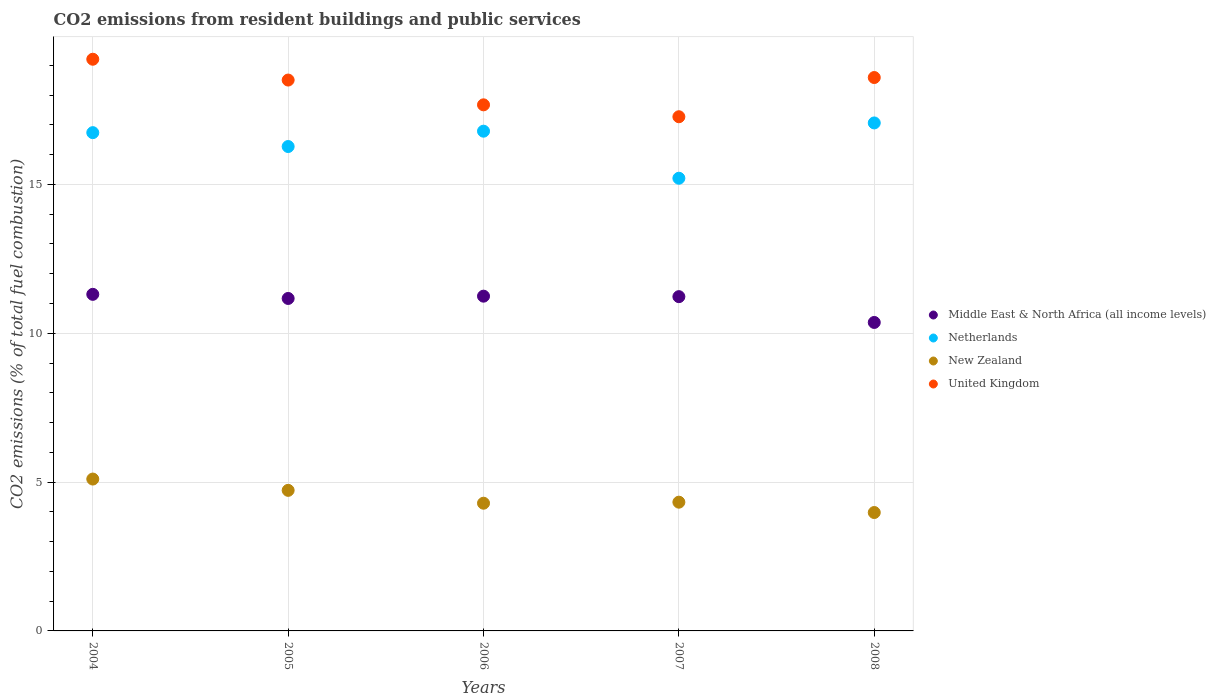What is the total CO2 emitted in Netherlands in 2006?
Your answer should be compact. 16.79. Across all years, what is the maximum total CO2 emitted in Netherlands?
Ensure brevity in your answer.  17.07. Across all years, what is the minimum total CO2 emitted in Middle East & North Africa (all income levels)?
Offer a very short reply. 10.36. What is the total total CO2 emitted in Netherlands in the graph?
Make the answer very short. 82.08. What is the difference between the total CO2 emitted in United Kingdom in 2004 and that in 2005?
Ensure brevity in your answer.  0.7. What is the difference between the total CO2 emitted in Middle East & North Africa (all income levels) in 2006 and the total CO2 emitted in New Zealand in 2005?
Your answer should be compact. 6.52. What is the average total CO2 emitted in Middle East & North Africa (all income levels) per year?
Your answer should be very brief. 11.06. In the year 2006, what is the difference between the total CO2 emitted in New Zealand and total CO2 emitted in Netherlands?
Your answer should be compact. -12.5. What is the ratio of the total CO2 emitted in Middle East & North Africa (all income levels) in 2005 to that in 2006?
Your answer should be compact. 0.99. Is the difference between the total CO2 emitted in New Zealand in 2004 and 2008 greater than the difference between the total CO2 emitted in Netherlands in 2004 and 2008?
Give a very brief answer. Yes. What is the difference between the highest and the second highest total CO2 emitted in Netherlands?
Provide a succinct answer. 0.28. What is the difference between the highest and the lowest total CO2 emitted in New Zealand?
Offer a terse response. 1.12. Is it the case that in every year, the sum of the total CO2 emitted in Netherlands and total CO2 emitted in New Zealand  is greater than the sum of total CO2 emitted in Middle East & North Africa (all income levels) and total CO2 emitted in United Kingdom?
Your response must be concise. No. Is it the case that in every year, the sum of the total CO2 emitted in Netherlands and total CO2 emitted in United Kingdom  is greater than the total CO2 emitted in New Zealand?
Your response must be concise. Yes. Is the total CO2 emitted in New Zealand strictly greater than the total CO2 emitted in United Kingdom over the years?
Give a very brief answer. No. How many years are there in the graph?
Keep it short and to the point. 5. Does the graph contain grids?
Your answer should be compact. Yes. Where does the legend appear in the graph?
Your answer should be compact. Center right. How many legend labels are there?
Keep it short and to the point. 4. How are the legend labels stacked?
Offer a very short reply. Vertical. What is the title of the graph?
Your answer should be compact. CO2 emissions from resident buildings and public services. Does "Europe(developing only)" appear as one of the legend labels in the graph?
Keep it short and to the point. No. What is the label or title of the Y-axis?
Your answer should be compact. CO2 emissions (% of total fuel combustion). What is the CO2 emissions (% of total fuel combustion) of Middle East & North Africa (all income levels) in 2004?
Keep it short and to the point. 11.31. What is the CO2 emissions (% of total fuel combustion) in Netherlands in 2004?
Your answer should be very brief. 16.74. What is the CO2 emissions (% of total fuel combustion) in New Zealand in 2004?
Make the answer very short. 5.1. What is the CO2 emissions (% of total fuel combustion) in United Kingdom in 2004?
Make the answer very short. 19.21. What is the CO2 emissions (% of total fuel combustion) in Middle East & North Africa (all income levels) in 2005?
Your answer should be compact. 11.17. What is the CO2 emissions (% of total fuel combustion) of Netherlands in 2005?
Your answer should be compact. 16.27. What is the CO2 emissions (% of total fuel combustion) in New Zealand in 2005?
Offer a terse response. 4.72. What is the CO2 emissions (% of total fuel combustion) of United Kingdom in 2005?
Provide a short and direct response. 18.51. What is the CO2 emissions (% of total fuel combustion) in Middle East & North Africa (all income levels) in 2006?
Your response must be concise. 11.25. What is the CO2 emissions (% of total fuel combustion) of Netherlands in 2006?
Your answer should be compact. 16.79. What is the CO2 emissions (% of total fuel combustion) in New Zealand in 2006?
Your response must be concise. 4.29. What is the CO2 emissions (% of total fuel combustion) of United Kingdom in 2006?
Provide a short and direct response. 17.67. What is the CO2 emissions (% of total fuel combustion) of Middle East & North Africa (all income levels) in 2007?
Your answer should be compact. 11.23. What is the CO2 emissions (% of total fuel combustion) in Netherlands in 2007?
Give a very brief answer. 15.21. What is the CO2 emissions (% of total fuel combustion) of New Zealand in 2007?
Make the answer very short. 4.33. What is the CO2 emissions (% of total fuel combustion) of United Kingdom in 2007?
Your answer should be very brief. 17.27. What is the CO2 emissions (% of total fuel combustion) of Middle East & North Africa (all income levels) in 2008?
Your response must be concise. 10.36. What is the CO2 emissions (% of total fuel combustion) in Netherlands in 2008?
Make the answer very short. 17.07. What is the CO2 emissions (% of total fuel combustion) in New Zealand in 2008?
Give a very brief answer. 3.98. What is the CO2 emissions (% of total fuel combustion) of United Kingdom in 2008?
Your response must be concise. 18.59. Across all years, what is the maximum CO2 emissions (% of total fuel combustion) of Middle East & North Africa (all income levels)?
Make the answer very short. 11.31. Across all years, what is the maximum CO2 emissions (% of total fuel combustion) in Netherlands?
Ensure brevity in your answer.  17.07. Across all years, what is the maximum CO2 emissions (% of total fuel combustion) of New Zealand?
Keep it short and to the point. 5.1. Across all years, what is the maximum CO2 emissions (% of total fuel combustion) of United Kingdom?
Give a very brief answer. 19.21. Across all years, what is the minimum CO2 emissions (% of total fuel combustion) in Middle East & North Africa (all income levels)?
Give a very brief answer. 10.36. Across all years, what is the minimum CO2 emissions (% of total fuel combustion) of Netherlands?
Offer a terse response. 15.21. Across all years, what is the minimum CO2 emissions (% of total fuel combustion) in New Zealand?
Provide a short and direct response. 3.98. Across all years, what is the minimum CO2 emissions (% of total fuel combustion) in United Kingdom?
Your answer should be very brief. 17.27. What is the total CO2 emissions (% of total fuel combustion) in Middle East & North Africa (all income levels) in the graph?
Offer a very short reply. 55.32. What is the total CO2 emissions (% of total fuel combustion) of Netherlands in the graph?
Make the answer very short. 82.08. What is the total CO2 emissions (% of total fuel combustion) in New Zealand in the graph?
Make the answer very short. 22.42. What is the total CO2 emissions (% of total fuel combustion) of United Kingdom in the graph?
Offer a very short reply. 91.25. What is the difference between the CO2 emissions (% of total fuel combustion) in Middle East & North Africa (all income levels) in 2004 and that in 2005?
Keep it short and to the point. 0.14. What is the difference between the CO2 emissions (% of total fuel combustion) of Netherlands in 2004 and that in 2005?
Your response must be concise. 0.47. What is the difference between the CO2 emissions (% of total fuel combustion) of New Zealand in 2004 and that in 2005?
Offer a very short reply. 0.38. What is the difference between the CO2 emissions (% of total fuel combustion) in United Kingdom in 2004 and that in 2005?
Your answer should be very brief. 0.7. What is the difference between the CO2 emissions (% of total fuel combustion) in Middle East & North Africa (all income levels) in 2004 and that in 2006?
Give a very brief answer. 0.06. What is the difference between the CO2 emissions (% of total fuel combustion) in Netherlands in 2004 and that in 2006?
Make the answer very short. -0.05. What is the difference between the CO2 emissions (% of total fuel combustion) of New Zealand in 2004 and that in 2006?
Provide a short and direct response. 0.81. What is the difference between the CO2 emissions (% of total fuel combustion) in United Kingdom in 2004 and that in 2006?
Your response must be concise. 1.53. What is the difference between the CO2 emissions (% of total fuel combustion) of Middle East & North Africa (all income levels) in 2004 and that in 2007?
Your response must be concise. 0.08. What is the difference between the CO2 emissions (% of total fuel combustion) in Netherlands in 2004 and that in 2007?
Offer a terse response. 1.53. What is the difference between the CO2 emissions (% of total fuel combustion) in New Zealand in 2004 and that in 2007?
Make the answer very short. 0.78. What is the difference between the CO2 emissions (% of total fuel combustion) of United Kingdom in 2004 and that in 2007?
Provide a succinct answer. 1.93. What is the difference between the CO2 emissions (% of total fuel combustion) of Netherlands in 2004 and that in 2008?
Ensure brevity in your answer.  -0.33. What is the difference between the CO2 emissions (% of total fuel combustion) in New Zealand in 2004 and that in 2008?
Offer a terse response. 1.12. What is the difference between the CO2 emissions (% of total fuel combustion) of United Kingdom in 2004 and that in 2008?
Provide a succinct answer. 0.61. What is the difference between the CO2 emissions (% of total fuel combustion) of Middle East & North Africa (all income levels) in 2005 and that in 2006?
Offer a terse response. -0.08. What is the difference between the CO2 emissions (% of total fuel combustion) of Netherlands in 2005 and that in 2006?
Keep it short and to the point. -0.52. What is the difference between the CO2 emissions (% of total fuel combustion) of New Zealand in 2005 and that in 2006?
Offer a terse response. 0.43. What is the difference between the CO2 emissions (% of total fuel combustion) in United Kingdom in 2005 and that in 2006?
Offer a terse response. 0.83. What is the difference between the CO2 emissions (% of total fuel combustion) of Middle East & North Africa (all income levels) in 2005 and that in 2007?
Your answer should be very brief. -0.06. What is the difference between the CO2 emissions (% of total fuel combustion) in Netherlands in 2005 and that in 2007?
Ensure brevity in your answer.  1.07. What is the difference between the CO2 emissions (% of total fuel combustion) of New Zealand in 2005 and that in 2007?
Make the answer very short. 0.4. What is the difference between the CO2 emissions (% of total fuel combustion) of United Kingdom in 2005 and that in 2007?
Offer a terse response. 1.23. What is the difference between the CO2 emissions (% of total fuel combustion) in Middle East & North Africa (all income levels) in 2005 and that in 2008?
Ensure brevity in your answer.  0.81. What is the difference between the CO2 emissions (% of total fuel combustion) in Netherlands in 2005 and that in 2008?
Provide a short and direct response. -0.79. What is the difference between the CO2 emissions (% of total fuel combustion) in New Zealand in 2005 and that in 2008?
Make the answer very short. 0.74. What is the difference between the CO2 emissions (% of total fuel combustion) of United Kingdom in 2005 and that in 2008?
Ensure brevity in your answer.  -0.08. What is the difference between the CO2 emissions (% of total fuel combustion) of Middle East & North Africa (all income levels) in 2006 and that in 2007?
Offer a very short reply. 0.02. What is the difference between the CO2 emissions (% of total fuel combustion) in Netherlands in 2006 and that in 2007?
Give a very brief answer. 1.58. What is the difference between the CO2 emissions (% of total fuel combustion) in New Zealand in 2006 and that in 2007?
Ensure brevity in your answer.  -0.04. What is the difference between the CO2 emissions (% of total fuel combustion) of United Kingdom in 2006 and that in 2007?
Offer a terse response. 0.4. What is the difference between the CO2 emissions (% of total fuel combustion) of Middle East & North Africa (all income levels) in 2006 and that in 2008?
Offer a very short reply. 0.88. What is the difference between the CO2 emissions (% of total fuel combustion) of Netherlands in 2006 and that in 2008?
Provide a short and direct response. -0.28. What is the difference between the CO2 emissions (% of total fuel combustion) in New Zealand in 2006 and that in 2008?
Make the answer very short. 0.31. What is the difference between the CO2 emissions (% of total fuel combustion) in United Kingdom in 2006 and that in 2008?
Provide a succinct answer. -0.92. What is the difference between the CO2 emissions (% of total fuel combustion) of Middle East & North Africa (all income levels) in 2007 and that in 2008?
Offer a terse response. 0.87. What is the difference between the CO2 emissions (% of total fuel combustion) in Netherlands in 2007 and that in 2008?
Your answer should be compact. -1.86. What is the difference between the CO2 emissions (% of total fuel combustion) of New Zealand in 2007 and that in 2008?
Your response must be concise. 0.35. What is the difference between the CO2 emissions (% of total fuel combustion) in United Kingdom in 2007 and that in 2008?
Make the answer very short. -1.32. What is the difference between the CO2 emissions (% of total fuel combustion) in Middle East & North Africa (all income levels) in 2004 and the CO2 emissions (% of total fuel combustion) in Netherlands in 2005?
Give a very brief answer. -4.97. What is the difference between the CO2 emissions (% of total fuel combustion) of Middle East & North Africa (all income levels) in 2004 and the CO2 emissions (% of total fuel combustion) of New Zealand in 2005?
Offer a very short reply. 6.59. What is the difference between the CO2 emissions (% of total fuel combustion) of Middle East & North Africa (all income levels) in 2004 and the CO2 emissions (% of total fuel combustion) of United Kingdom in 2005?
Offer a terse response. -7.2. What is the difference between the CO2 emissions (% of total fuel combustion) of Netherlands in 2004 and the CO2 emissions (% of total fuel combustion) of New Zealand in 2005?
Offer a terse response. 12.02. What is the difference between the CO2 emissions (% of total fuel combustion) of Netherlands in 2004 and the CO2 emissions (% of total fuel combustion) of United Kingdom in 2005?
Keep it short and to the point. -1.77. What is the difference between the CO2 emissions (% of total fuel combustion) in New Zealand in 2004 and the CO2 emissions (% of total fuel combustion) in United Kingdom in 2005?
Offer a terse response. -13.4. What is the difference between the CO2 emissions (% of total fuel combustion) of Middle East & North Africa (all income levels) in 2004 and the CO2 emissions (% of total fuel combustion) of Netherlands in 2006?
Your answer should be very brief. -5.48. What is the difference between the CO2 emissions (% of total fuel combustion) in Middle East & North Africa (all income levels) in 2004 and the CO2 emissions (% of total fuel combustion) in New Zealand in 2006?
Offer a very short reply. 7.02. What is the difference between the CO2 emissions (% of total fuel combustion) in Middle East & North Africa (all income levels) in 2004 and the CO2 emissions (% of total fuel combustion) in United Kingdom in 2006?
Your answer should be compact. -6.37. What is the difference between the CO2 emissions (% of total fuel combustion) of Netherlands in 2004 and the CO2 emissions (% of total fuel combustion) of New Zealand in 2006?
Give a very brief answer. 12.45. What is the difference between the CO2 emissions (% of total fuel combustion) in Netherlands in 2004 and the CO2 emissions (% of total fuel combustion) in United Kingdom in 2006?
Offer a very short reply. -0.93. What is the difference between the CO2 emissions (% of total fuel combustion) in New Zealand in 2004 and the CO2 emissions (% of total fuel combustion) in United Kingdom in 2006?
Give a very brief answer. -12.57. What is the difference between the CO2 emissions (% of total fuel combustion) in Middle East & North Africa (all income levels) in 2004 and the CO2 emissions (% of total fuel combustion) in Netherlands in 2007?
Offer a terse response. -3.9. What is the difference between the CO2 emissions (% of total fuel combustion) of Middle East & North Africa (all income levels) in 2004 and the CO2 emissions (% of total fuel combustion) of New Zealand in 2007?
Your answer should be compact. 6.98. What is the difference between the CO2 emissions (% of total fuel combustion) in Middle East & North Africa (all income levels) in 2004 and the CO2 emissions (% of total fuel combustion) in United Kingdom in 2007?
Provide a succinct answer. -5.97. What is the difference between the CO2 emissions (% of total fuel combustion) in Netherlands in 2004 and the CO2 emissions (% of total fuel combustion) in New Zealand in 2007?
Your answer should be very brief. 12.41. What is the difference between the CO2 emissions (% of total fuel combustion) of Netherlands in 2004 and the CO2 emissions (% of total fuel combustion) of United Kingdom in 2007?
Your answer should be very brief. -0.53. What is the difference between the CO2 emissions (% of total fuel combustion) in New Zealand in 2004 and the CO2 emissions (% of total fuel combustion) in United Kingdom in 2007?
Your response must be concise. -12.17. What is the difference between the CO2 emissions (% of total fuel combustion) of Middle East & North Africa (all income levels) in 2004 and the CO2 emissions (% of total fuel combustion) of Netherlands in 2008?
Give a very brief answer. -5.76. What is the difference between the CO2 emissions (% of total fuel combustion) in Middle East & North Africa (all income levels) in 2004 and the CO2 emissions (% of total fuel combustion) in New Zealand in 2008?
Give a very brief answer. 7.33. What is the difference between the CO2 emissions (% of total fuel combustion) of Middle East & North Africa (all income levels) in 2004 and the CO2 emissions (% of total fuel combustion) of United Kingdom in 2008?
Provide a short and direct response. -7.28. What is the difference between the CO2 emissions (% of total fuel combustion) in Netherlands in 2004 and the CO2 emissions (% of total fuel combustion) in New Zealand in 2008?
Offer a very short reply. 12.76. What is the difference between the CO2 emissions (% of total fuel combustion) in Netherlands in 2004 and the CO2 emissions (% of total fuel combustion) in United Kingdom in 2008?
Make the answer very short. -1.85. What is the difference between the CO2 emissions (% of total fuel combustion) of New Zealand in 2004 and the CO2 emissions (% of total fuel combustion) of United Kingdom in 2008?
Your answer should be compact. -13.49. What is the difference between the CO2 emissions (% of total fuel combustion) of Middle East & North Africa (all income levels) in 2005 and the CO2 emissions (% of total fuel combustion) of Netherlands in 2006?
Ensure brevity in your answer.  -5.62. What is the difference between the CO2 emissions (% of total fuel combustion) of Middle East & North Africa (all income levels) in 2005 and the CO2 emissions (% of total fuel combustion) of New Zealand in 2006?
Your response must be concise. 6.88. What is the difference between the CO2 emissions (% of total fuel combustion) in Middle East & North Africa (all income levels) in 2005 and the CO2 emissions (% of total fuel combustion) in United Kingdom in 2006?
Offer a very short reply. -6.5. What is the difference between the CO2 emissions (% of total fuel combustion) of Netherlands in 2005 and the CO2 emissions (% of total fuel combustion) of New Zealand in 2006?
Your answer should be compact. 11.98. What is the difference between the CO2 emissions (% of total fuel combustion) of Netherlands in 2005 and the CO2 emissions (% of total fuel combustion) of United Kingdom in 2006?
Make the answer very short. -1.4. What is the difference between the CO2 emissions (% of total fuel combustion) of New Zealand in 2005 and the CO2 emissions (% of total fuel combustion) of United Kingdom in 2006?
Keep it short and to the point. -12.95. What is the difference between the CO2 emissions (% of total fuel combustion) of Middle East & North Africa (all income levels) in 2005 and the CO2 emissions (% of total fuel combustion) of Netherlands in 2007?
Make the answer very short. -4.04. What is the difference between the CO2 emissions (% of total fuel combustion) of Middle East & North Africa (all income levels) in 2005 and the CO2 emissions (% of total fuel combustion) of New Zealand in 2007?
Your answer should be compact. 6.84. What is the difference between the CO2 emissions (% of total fuel combustion) of Middle East & North Africa (all income levels) in 2005 and the CO2 emissions (% of total fuel combustion) of United Kingdom in 2007?
Offer a very short reply. -6.11. What is the difference between the CO2 emissions (% of total fuel combustion) in Netherlands in 2005 and the CO2 emissions (% of total fuel combustion) in New Zealand in 2007?
Provide a short and direct response. 11.95. What is the difference between the CO2 emissions (% of total fuel combustion) in Netherlands in 2005 and the CO2 emissions (% of total fuel combustion) in United Kingdom in 2007?
Offer a terse response. -1. What is the difference between the CO2 emissions (% of total fuel combustion) of New Zealand in 2005 and the CO2 emissions (% of total fuel combustion) of United Kingdom in 2007?
Keep it short and to the point. -12.55. What is the difference between the CO2 emissions (% of total fuel combustion) of Middle East & North Africa (all income levels) in 2005 and the CO2 emissions (% of total fuel combustion) of Netherlands in 2008?
Your answer should be compact. -5.9. What is the difference between the CO2 emissions (% of total fuel combustion) of Middle East & North Africa (all income levels) in 2005 and the CO2 emissions (% of total fuel combustion) of New Zealand in 2008?
Your answer should be very brief. 7.19. What is the difference between the CO2 emissions (% of total fuel combustion) of Middle East & North Africa (all income levels) in 2005 and the CO2 emissions (% of total fuel combustion) of United Kingdom in 2008?
Offer a terse response. -7.42. What is the difference between the CO2 emissions (% of total fuel combustion) of Netherlands in 2005 and the CO2 emissions (% of total fuel combustion) of New Zealand in 2008?
Offer a terse response. 12.3. What is the difference between the CO2 emissions (% of total fuel combustion) of Netherlands in 2005 and the CO2 emissions (% of total fuel combustion) of United Kingdom in 2008?
Provide a short and direct response. -2.32. What is the difference between the CO2 emissions (% of total fuel combustion) in New Zealand in 2005 and the CO2 emissions (% of total fuel combustion) in United Kingdom in 2008?
Ensure brevity in your answer.  -13.87. What is the difference between the CO2 emissions (% of total fuel combustion) in Middle East & North Africa (all income levels) in 2006 and the CO2 emissions (% of total fuel combustion) in Netherlands in 2007?
Ensure brevity in your answer.  -3.96. What is the difference between the CO2 emissions (% of total fuel combustion) in Middle East & North Africa (all income levels) in 2006 and the CO2 emissions (% of total fuel combustion) in New Zealand in 2007?
Provide a short and direct response. 6.92. What is the difference between the CO2 emissions (% of total fuel combustion) in Middle East & North Africa (all income levels) in 2006 and the CO2 emissions (% of total fuel combustion) in United Kingdom in 2007?
Provide a short and direct response. -6.03. What is the difference between the CO2 emissions (% of total fuel combustion) of Netherlands in 2006 and the CO2 emissions (% of total fuel combustion) of New Zealand in 2007?
Provide a succinct answer. 12.46. What is the difference between the CO2 emissions (% of total fuel combustion) in Netherlands in 2006 and the CO2 emissions (% of total fuel combustion) in United Kingdom in 2007?
Your answer should be compact. -0.49. What is the difference between the CO2 emissions (% of total fuel combustion) in New Zealand in 2006 and the CO2 emissions (% of total fuel combustion) in United Kingdom in 2007?
Ensure brevity in your answer.  -12.98. What is the difference between the CO2 emissions (% of total fuel combustion) in Middle East & North Africa (all income levels) in 2006 and the CO2 emissions (% of total fuel combustion) in Netherlands in 2008?
Keep it short and to the point. -5.82. What is the difference between the CO2 emissions (% of total fuel combustion) in Middle East & North Africa (all income levels) in 2006 and the CO2 emissions (% of total fuel combustion) in New Zealand in 2008?
Provide a succinct answer. 7.27. What is the difference between the CO2 emissions (% of total fuel combustion) of Middle East & North Africa (all income levels) in 2006 and the CO2 emissions (% of total fuel combustion) of United Kingdom in 2008?
Your answer should be compact. -7.35. What is the difference between the CO2 emissions (% of total fuel combustion) in Netherlands in 2006 and the CO2 emissions (% of total fuel combustion) in New Zealand in 2008?
Offer a terse response. 12.81. What is the difference between the CO2 emissions (% of total fuel combustion) of Netherlands in 2006 and the CO2 emissions (% of total fuel combustion) of United Kingdom in 2008?
Offer a terse response. -1.8. What is the difference between the CO2 emissions (% of total fuel combustion) in New Zealand in 2006 and the CO2 emissions (% of total fuel combustion) in United Kingdom in 2008?
Your answer should be compact. -14.3. What is the difference between the CO2 emissions (% of total fuel combustion) of Middle East & North Africa (all income levels) in 2007 and the CO2 emissions (% of total fuel combustion) of Netherlands in 2008?
Make the answer very short. -5.84. What is the difference between the CO2 emissions (% of total fuel combustion) in Middle East & North Africa (all income levels) in 2007 and the CO2 emissions (% of total fuel combustion) in New Zealand in 2008?
Your response must be concise. 7.25. What is the difference between the CO2 emissions (% of total fuel combustion) in Middle East & North Africa (all income levels) in 2007 and the CO2 emissions (% of total fuel combustion) in United Kingdom in 2008?
Offer a very short reply. -7.36. What is the difference between the CO2 emissions (% of total fuel combustion) of Netherlands in 2007 and the CO2 emissions (% of total fuel combustion) of New Zealand in 2008?
Offer a very short reply. 11.23. What is the difference between the CO2 emissions (% of total fuel combustion) in Netherlands in 2007 and the CO2 emissions (% of total fuel combustion) in United Kingdom in 2008?
Make the answer very short. -3.38. What is the difference between the CO2 emissions (% of total fuel combustion) of New Zealand in 2007 and the CO2 emissions (% of total fuel combustion) of United Kingdom in 2008?
Give a very brief answer. -14.27. What is the average CO2 emissions (% of total fuel combustion) in Middle East & North Africa (all income levels) per year?
Offer a terse response. 11.06. What is the average CO2 emissions (% of total fuel combustion) of Netherlands per year?
Ensure brevity in your answer.  16.42. What is the average CO2 emissions (% of total fuel combustion) of New Zealand per year?
Offer a terse response. 4.48. What is the average CO2 emissions (% of total fuel combustion) of United Kingdom per year?
Provide a short and direct response. 18.25. In the year 2004, what is the difference between the CO2 emissions (% of total fuel combustion) of Middle East & North Africa (all income levels) and CO2 emissions (% of total fuel combustion) of Netherlands?
Your answer should be very brief. -5.43. In the year 2004, what is the difference between the CO2 emissions (% of total fuel combustion) of Middle East & North Africa (all income levels) and CO2 emissions (% of total fuel combustion) of New Zealand?
Give a very brief answer. 6.21. In the year 2004, what is the difference between the CO2 emissions (% of total fuel combustion) in Middle East & North Africa (all income levels) and CO2 emissions (% of total fuel combustion) in United Kingdom?
Your answer should be compact. -7.9. In the year 2004, what is the difference between the CO2 emissions (% of total fuel combustion) in Netherlands and CO2 emissions (% of total fuel combustion) in New Zealand?
Make the answer very short. 11.64. In the year 2004, what is the difference between the CO2 emissions (% of total fuel combustion) of Netherlands and CO2 emissions (% of total fuel combustion) of United Kingdom?
Keep it short and to the point. -2.47. In the year 2004, what is the difference between the CO2 emissions (% of total fuel combustion) in New Zealand and CO2 emissions (% of total fuel combustion) in United Kingdom?
Ensure brevity in your answer.  -14.1. In the year 2005, what is the difference between the CO2 emissions (% of total fuel combustion) of Middle East & North Africa (all income levels) and CO2 emissions (% of total fuel combustion) of Netherlands?
Keep it short and to the point. -5.1. In the year 2005, what is the difference between the CO2 emissions (% of total fuel combustion) in Middle East & North Africa (all income levels) and CO2 emissions (% of total fuel combustion) in New Zealand?
Offer a terse response. 6.45. In the year 2005, what is the difference between the CO2 emissions (% of total fuel combustion) of Middle East & North Africa (all income levels) and CO2 emissions (% of total fuel combustion) of United Kingdom?
Offer a terse response. -7.34. In the year 2005, what is the difference between the CO2 emissions (% of total fuel combustion) of Netherlands and CO2 emissions (% of total fuel combustion) of New Zealand?
Keep it short and to the point. 11.55. In the year 2005, what is the difference between the CO2 emissions (% of total fuel combustion) in Netherlands and CO2 emissions (% of total fuel combustion) in United Kingdom?
Your answer should be compact. -2.23. In the year 2005, what is the difference between the CO2 emissions (% of total fuel combustion) of New Zealand and CO2 emissions (% of total fuel combustion) of United Kingdom?
Ensure brevity in your answer.  -13.78. In the year 2006, what is the difference between the CO2 emissions (% of total fuel combustion) of Middle East & North Africa (all income levels) and CO2 emissions (% of total fuel combustion) of Netherlands?
Your answer should be compact. -5.54. In the year 2006, what is the difference between the CO2 emissions (% of total fuel combustion) in Middle East & North Africa (all income levels) and CO2 emissions (% of total fuel combustion) in New Zealand?
Offer a terse response. 6.96. In the year 2006, what is the difference between the CO2 emissions (% of total fuel combustion) of Middle East & North Africa (all income levels) and CO2 emissions (% of total fuel combustion) of United Kingdom?
Offer a terse response. -6.43. In the year 2006, what is the difference between the CO2 emissions (% of total fuel combustion) of Netherlands and CO2 emissions (% of total fuel combustion) of New Zealand?
Offer a very short reply. 12.5. In the year 2006, what is the difference between the CO2 emissions (% of total fuel combustion) in Netherlands and CO2 emissions (% of total fuel combustion) in United Kingdom?
Your response must be concise. -0.89. In the year 2006, what is the difference between the CO2 emissions (% of total fuel combustion) of New Zealand and CO2 emissions (% of total fuel combustion) of United Kingdom?
Provide a succinct answer. -13.38. In the year 2007, what is the difference between the CO2 emissions (% of total fuel combustion) of Middle East & North Africa (all income levels) and CO2 emissions (% of total fuel combustion) of Netherlands?
Your answer should be very brief. -3.98. In the year 2007, what is the difference between the CO2 emissions (% of total fuel combustion) in Middle East & North Africa (all income levels) and CO2 emissions (% of total fuel combustion) in New Zealand?
Your answer should be very brief. 6.9. In the year 2007, what is the difference between the CO2 emissions (% of total fuel combustion) in Middle East & North Africa (all income levels) and CO2 emissions (% of total fuel combustion) in United Kingdom?
Your response must be concise. -6.04. In the year 2007, what is the difference between the CO2 emissions (% of total fuel combustion) in Netherlands and CO2 emissions (% of total fuel combustion) in New Zealand?
Provide a short and direct response. 10.88. In the year 2007, what is the difference between the CO2 emissions (% of total fuel combustion) in Netherlands and CO2 emissions (% of total fuel combustion) in United Kingdom?
Your response must be concise. -2.07. In the year 2007, what is the difference between the CO2 emissions (% of total fuel combustion) in New Zealand and CO2 emissions (% of total fuel combustion) in United Kingdom?
Provide a succinct answer. -12.95. In the year 2008, what is the difference between the CO2 emissions (% of total fuel combustion) in Middle East & North Africa (all income levels) and CO2 emissions (% of total fuel combustion) in Netherlands?
Offer a terse response. -6.7. In the year 2008, what is the difference between the CO2 emissions (% of total fuel combustion) of Middle East & North Africa (all income levels) and CO2 emissions (% of total fuel combustion) of New Zealand?
Your response must be concise. 6.39. In the year 2008, what is the difference between the CO2 emissions (% of total fuel combustion) in Middle East & North Africa (all income levels) and CO2 emissions (% of total fuel combustion) in United Kingdom?
Provide a succinct answer. -8.23. In the year 2008, what is the difference between the CO2 emissions (% of total fuel combustion) in Netherlands and CO2 emissions (% of total fuel combustion) in New Zealand?
Keep it short and to the point. 13.09. In the year 2008, what is the difference between the CO2 emissions (% of total fuel combustion) of Netherlands and CO2 emissions (% of total fuel combustion) of United Kingdom?
Your answer should be compact. -1.53. In the year 2008, what is the difference between the CO2 emissions (% of total fuel combustion) of New Zealand and CO2 emissions (% of total fuel combustion) of United Kingdom?
Ensure brevity in your answer.  -14.61. What is the ratio of the CO2 emissions (% of total fuel combustion) in Middle East & North Africa (all income levels) in 2004 to that in 2005?
Your response must be concise. 1.01. What is the ratio of the CO2 emissions (% of total fuel combustion) of Netherlands in 2004 to that in 2005?
Provide a short and direct response. 1.03. What is the ratio of the CO2 emissions (% of total fuel combustion) in New Zealand in 2004 to that in 2005?
Ensure brevity in your answer.  1.08. What is the ratio of the CO2 emissions (% of total fuel combustion) of United Kingdom in 2004 to that in 2005?
Your answer should be very brief. 1.04. What is the ratio of the CO2 emissions (% of total fuel combustion) of Netherlands in 2004 to that in 2006?
Ensure brevity in your answer.  1. What is the ratio of the CO2 emissions (% of total fuel combustion) in New Zealand in 2004 to that in 2006?
Your response must be concise. 1.19. What is the ratio of the CO2 emissions (% of total fuel combustion) of United Kingdom in 2004 to that in 2006?
Make the answer very short. 1.09. What is the ratio of the CO2 emissions (% of total fuel combustion) in Middle East & North Africa (all income levels) in 2004 to that in 2007?
Your answer should be very brief. 1.01. What is the ratio of the CO2 emissions (% of total fuel combustion) of Netherlands in 2004 to that in 2007?
Offer a terse response. 1.1. What is the ratio of the CO2 emissions (% of total fuel combustion) of New Zealand in 2004 to that in 2007?
Provide a succinct answer. 1.18. What is the ratio of the CO2 emissions (% of total fuel combustion) in United Kingdom in 2004 to that in 2007?
Offer a terse response. 1.11. What is the ratio of the CO2 emissions (% of total fuel combustion) in Middle East & North Africa (all income levels) in 2004 to that in 2008?
Keep it short and to the point. 1.09. What is the ratio of the CO2 emissions (% of total fuel combustion) in Netherlands in 2004 to that in 2008?
Provide a short and direct response. 0.98. What is the ratio of the CO2 emissions (% of total fuel combustion) of New Zealand in 2004 to that in 2008?
Make the answer very short. 1.28. What is the ratio of the CO2 emissions (% of total fuel combustion) of United Kingdom in 2004 to that in 2008?
Make the answer very short. 1.03. What is the ratio of the CO2 emissions (% of total fuel combustion) of Netherlands in 2005 to that in 2006?
Keep it short and to the point. 0.97. What is the ratio of the CO2 emissions (% of total fuel combustion) in New Zealand in 2005 to that in 2006?
Give a very brief answer. 1.1. What is the ratio of the CO2 emissions (% of total fuel combustion) in United Kingdom in 2005 to that in 2006?
Give a very brief answer. 1.05. What is the ratio of the CO2 emissions (% of total fuel combustion) of Netherlands in 2005 to that in 2007?
Provide a short and direct response. 1.07. What is the ratio of the CO2 emissions (% of total fuel combustion) in New Zealand in 2005 to that in 2007?
Ensure brevity in your answer.  1.09. What is the ratio of the CO2 emissions (% of total fuel combustion) in United Kingdom in 2005 to that in 2007?
Your answer should be compact. 1.07. What is the ratio of the CO2 emissions (% of total fuel combustion) of Middle East & North Africa (all income levels) in 2005 to that in 2008?
Ensure brevity in your answer.  1.08. What is the ratio of the CO2 emissions (% of total fuel combustion) in Netherlands in 2005 to that in 2008?
Offer a terse response. 0.95. What is the ratio of the CO2 emissions (% of total fuel combustion) in New Zealand in 2005 to that in 2008?
Give a very brief answer. 1.19. What is the ratio of the CO2 emissions (% of total fuel combustion) of Middle East & North Africa (all income levels) in 2006 to that in 2007?
Provide a succinct answer. 1. What is the ratio of the CO2 emissions (% of total fuel combustion) of Netherlands in 2006 to that in 2007?
Give a very brief answer. 1.1. What is the ratio of the CO2 emissions (% of total fuel combustion) in United Kingdom in 2006 to that in 2007?
Ensure brevity in your answer.  1.02. What is the ratio of the CO2 emissions (% of total fuel combustion) of Middle East & North Africa (all income levels) in 2006 to that in 2008?
Your response must be concise. 1.09. What is the ratio of the CO2 emissions (% of total fuel combustion) of Netherlands in 2006 to that in 2008?
Keep it short and to the point. 0.98. What is the ratio of the CO2 emissions (% of total fuel combustion) in New Zealand in 2006 to that in 2008?
Your answer should be compact. 1.08. What is the ratio of the CO2 emissions (% of total fuel combustion) of United Kingdom in 2006 to that in 2008?
Your answer should be very brief. 0.95. What is the ratio of the CO2 emissions (% of total fuel combustion) of Middle East & North Africa (all income levels) in 2007 to that in 2008?
Provide a succinct answer. 1.08. What is the ratio of the CO2 emissions (% of total fuel combustion) of Netherlands in 2007 to that in 2008?
Ensure brevity in your answer.  0.89. What is the ratio of the CO2 emissions (% of total fuel combustion) in New Zealand in 2007 to that in 2008?
Offer a terse response. 1.09. What is the ratio of the CO2 emissions (% of total fuel combustion) of United Kingdom in 2007 to that in 2008?
Offer a terse response. 0.93. What is the difference between the highest and the second highest CO2 emissions (% of total fuel combustion) in Middle East & North Africa (all income levels)?
Offer a terse response. 0.06. What is the difference between the highest and the second highest CO2 emissions (% of total fuel combustion) of Netherlands?
Make the answer very short. 0.28. What is the difference between the highest and the second highest CO2 emissions (% of total fuel combustion) of New Zealand?
Ensure brevity in your answer.  0.38. What is the difference between the highest and the second highest CO2 emissions (% of total fuel combustion) of United Kingdom?
Your response must be concise. 0.61. What is the difference between the highest and the lowest CO2 emissions (% of total fuel combustion) of Netherlands?
Your answer should be compact. 1.86. What is the difference between the highest and the lowest CO2 emissions (% of total fuel combustion) in New Zealand?
Your answer should be compact. 1.12. What is the difference between the highest and the lowest CO2 emissions (% of total fuel combustion) of United Kingdom?
Your response must be concise. 1.93. 